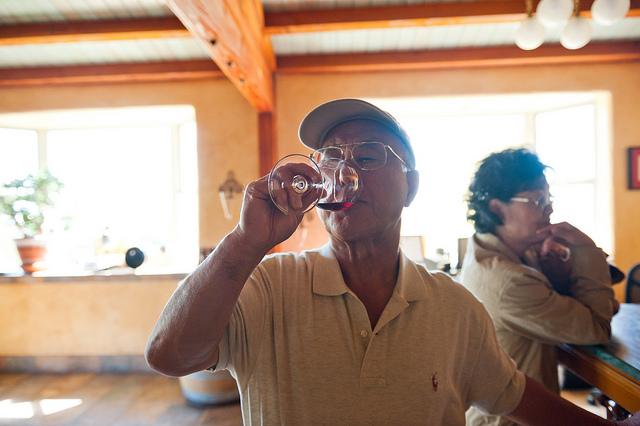Are they in a restaurant?
Keep it brief. Yes. Are the windows open?
Write a very short answer. Yes. Is he drinking beer?
Concise answer only. No. 